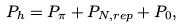Convert formula to latex. <formula><loc_0><loc_0><loc_500><loc_500>P _ { h } = P _ { \pi } + P _ { N , r e p } + P _ { 0 } ,</formula> 